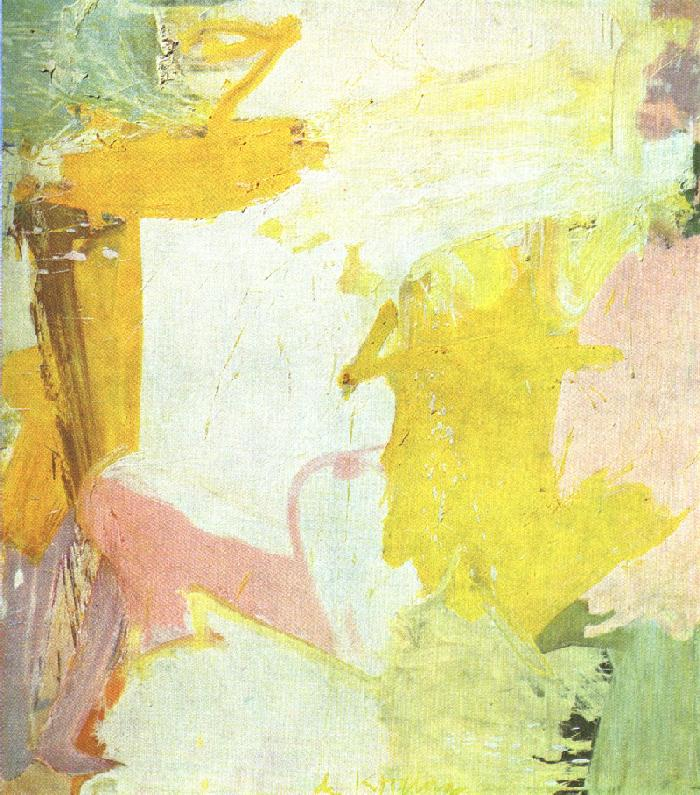Write a detailed description of the given image. The image displays an abstract painting, where broad and gestural brushstrokes overlap to create a textured tableau. The color palette is subdued yet varied, with light shades of yellow, pink, and white as well as touches of green and ochre. The colors are applied in such a way that they allow the canvas texture to show through in some areas, creating depth and visual interest. Certain strokes are thick and impasto, providing a tactile element to the piece. While the painting is non-representational, the forms and interaction of colors may evoke different emotions and subjective interpretations, inviting viewers to ponder the artist's intent and to imbue their own meaning into the visual experience. 